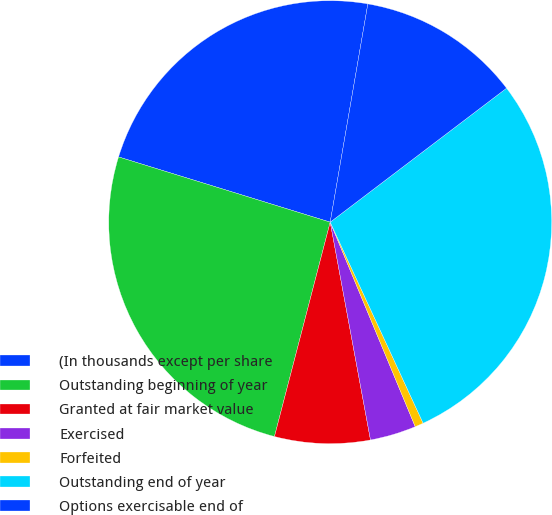Convert chart to OTSL. <chart><loc_0><loc_0><loc_500><loc_500><pie_chart><fcel>(In thousands except per share<fcel>Outstanding beginning of year<fcel>Granted at fair market value<fcel>Exercised<fcel>Forfeited<fcel>Outstanding end of year<fcel>Options exercisable end of<nl><fcel>22.96%<fcel>25.71%<fcel>6.96%<fcel>3.36%<fcel>0.62%<fcel>28.45%<fcel>11.94%<nl></chart> 